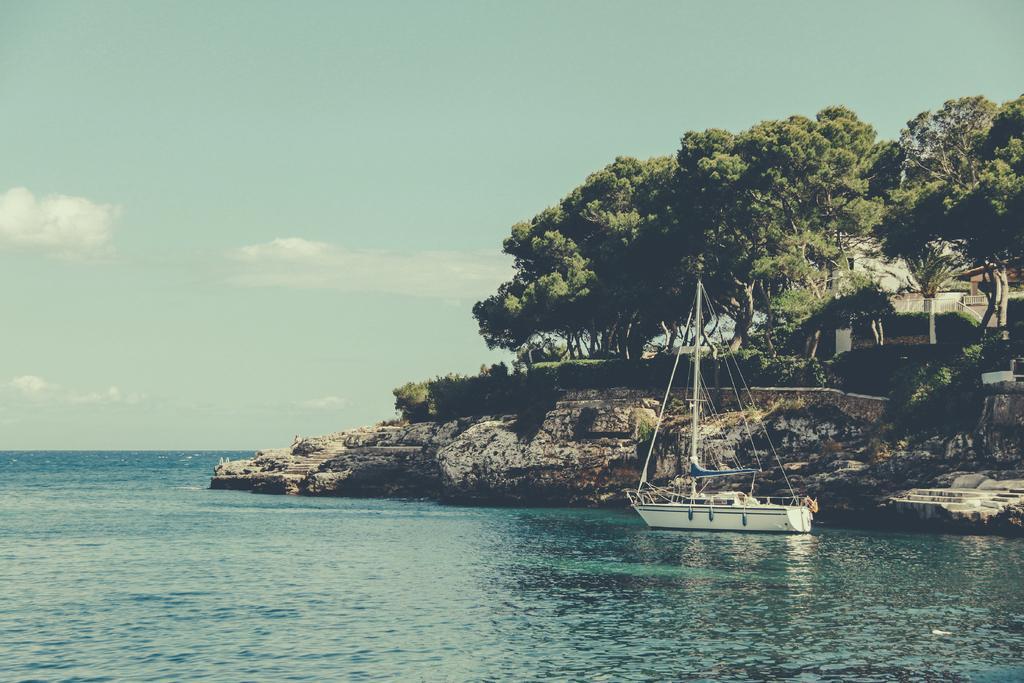How would you summarize this image in a sentence or two? In the picture we can see a boat is floating on the water. Here we can see the rock hills, trees, house, stairs and the sky with clouds in the background. 